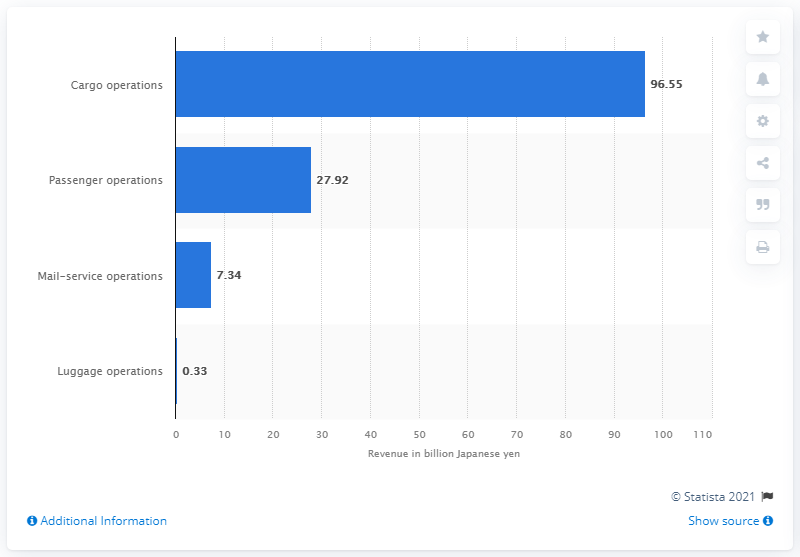Point out several critical features in this image. JAL's cargo operations revenue for 2020 was approximately 96.55 billion yen in value. 